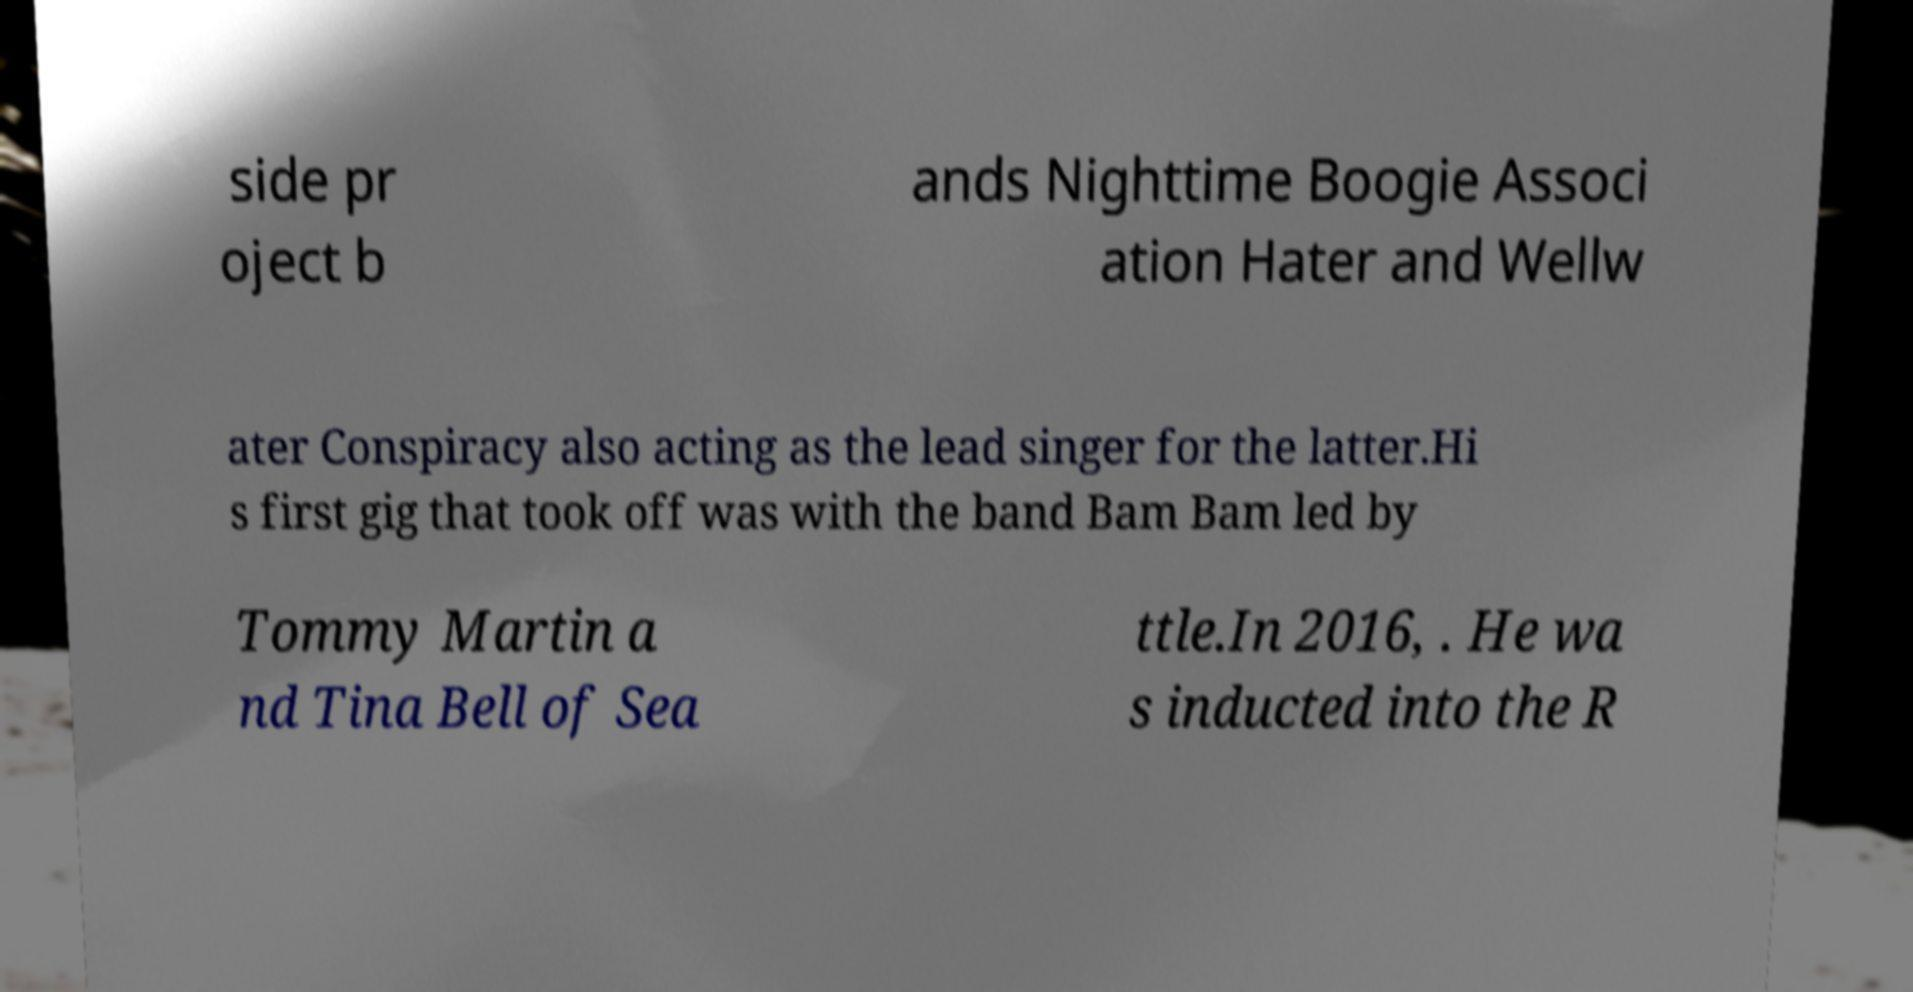Can you accurately transcribe the text from the provided image for me? side pr oject b ands Nighttime Boogie Associ ation Hater and Wellw ater Conspiracy also acting as the lead singer for the latter.Hi s first gig that took off was with the band Bam Bam led by Tommy Martin a nd Tina Bell of Sea ttle.In 2016, . He wa s inducted into the R 